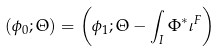<formula> <loc_0><loc_0><loc_500><loc_500>( \phi _ { 0 } ; \Theta ) = \left ( \phi _ { 1 } ; \Theta - \int _ { I } \Phi ^ { * } \iota ^ { F } \right )</formula> 